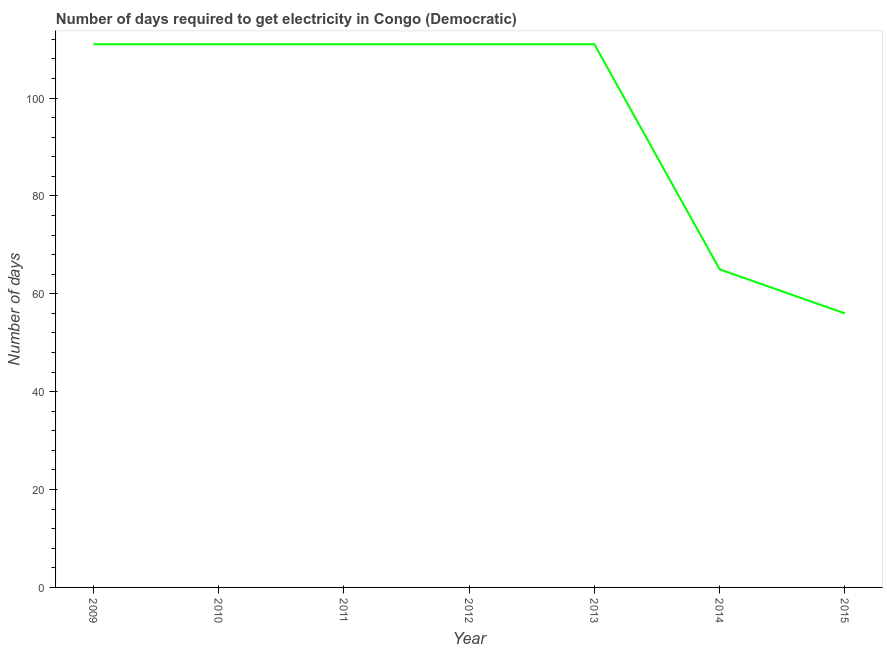What is the time to get electricity in 2010?
Make the answer very short. 111. Across all years, what is the maximum time to get electricity?
Your response must be concise. 111. Across all years, what is the minimum time to get electricity?
Your answer should be very brief. 56. In which year was the time to get electricity minimum?
Keep it short and to the point. 2015. What is the sum of the time to get electricity?
Your response must be concise. 676. What is the difference between the time to get electricity in 2009 and 2010?
Offer a very short reply. 0. What is the average time to get electricity per year?
Make the answer very short. 96.57. What is the median time to get electricity?
Keep it short and to the point. 111. Is the time to get electricity in 2009 less than that in 2015?
Your answer should be compact. No. What is the difference between the highest and the second highest time to get electricity?
Your answer should be very brief. 0. Is the sum of the time to get electricity in 2011 and 2014 greater than the maximum time to get electricity across all years?
Provide a succinct answer. Yes. What is the difference between the highest and the lowest time to get electricity?
Offer a very short reply. 55. How many years are there in the graph?
Offer a very short reply. 7. Are the values on the major ticks of Y-axis written in scientific E-notation?
Give a very brief answer. No. Does the graph contain any zero values?
Ensure brevity in your answer.  No. Does the graph contain grids?
Provide a short and direct response. No. What is the title of the graph?
Offer a terse response. Number of days required to get electricity in Congo (Democratic). What is the label or title of the X-axis?
Keep it short and to the point. Year. What is the label or title of the Y-axis?
Provide a succinct answer. Number of days. What is the Number of days of 2009?
Give a very brief answer. 111. What is the Number of days of 2010?
Your answer should be compact. 111. What is the Number of days in 2011?
Provide a short and direct response. 111. What is the Number of days of 2012?
Give a very brief answer. 111. What is the Number of days of 2013?
Your response must be concise. 111. What is the Number of days of 2015?
Provide a succinct answer. 56. What is the difference between the Number of days in 2009 and 2010?
Your answer should be compact. 0. What is the difference between the Number of days in 2009 and 2012?
Keep it short and to the point. 0. What is the difference between the Number of days in 2009 and 2013?
Provide a short and direct response. 0. What is the difference between the Number of days in 2009 and 2015?
Make the answer very short. 55. What is the difference between the Number of days in 2010 and 2014?
Provide a short and direct response. 46. What is the difference between the Number of days in 2010 and 2015?
Make the answer very short. 55. What is the difference between the Number of days in 2011 and 2012?
Keep it short and to the point. 0. What is the difference between the Number of days in 2012 and 2014?
Your response must be concise. 46. What is the difference between the Number of days in 2012 and 2015?
Provide a succinct answer. 55. What is the difference between the Number of days in 2013 and 2014?
Keep it short and to the point. 46. What is the difference between the Number of days in 2013 and 2015?
Your answer should be very brief. 55. What is the ratio of the Number of days in 2009 to that in 2010?
Your answer should be very brief. 1. What is the ratio of the Number of days in 2009 to that in 2014?
Your answer should be compact. 1.71. What is the ratio of the Number of days in 2009 to that in 2015?
Keep it short and to the point. 1.98. What is the ratio of the Number of days in 2010 to that in 2011?
Your answer should be compact. 1. What is the ratio of the Number of days in 2010 to that in 2012?
Offer a terse response. 1. What is the ratio of the Number of days in 2010 to that in 2013?
Provide a short and direct response. 1. What is the ratio of the Number of days in 2010 to that in 2014?
Keep it short and to the point. 1.71. What is the ratio of the Number of days in 2010 to that in 2015?
Your answer should be compact. 1.98. What is the ratio of the Number of days in 2011 to that in 2013?
Your response must be concise. 1. What is the ratio of the Number of days in 2011 to that in 2014?
Keep it short and to the point. 1.71. What is the ratio of the Number of days in 2011 to that in 2015?
Provide a short and direct response. 1.98. What is the ratio of the Number of days in 2012 to that in 2014?
Give a very brief answer. 1.71. What is the ratio of the Number of days in 2012 to that in 2015?
Offer a very short reply. 1.98. What is the ratio of the Number of days in 2013 to that in 2014?
Give a very brief answer. 1.71. What is the ratio of the Number of days in 2013 to that in 2015?
Make the answer very short. 1.98. What is the ratio of the Number of days in 2014 to that in 2015?
Give a very brief answer. 1.16. 